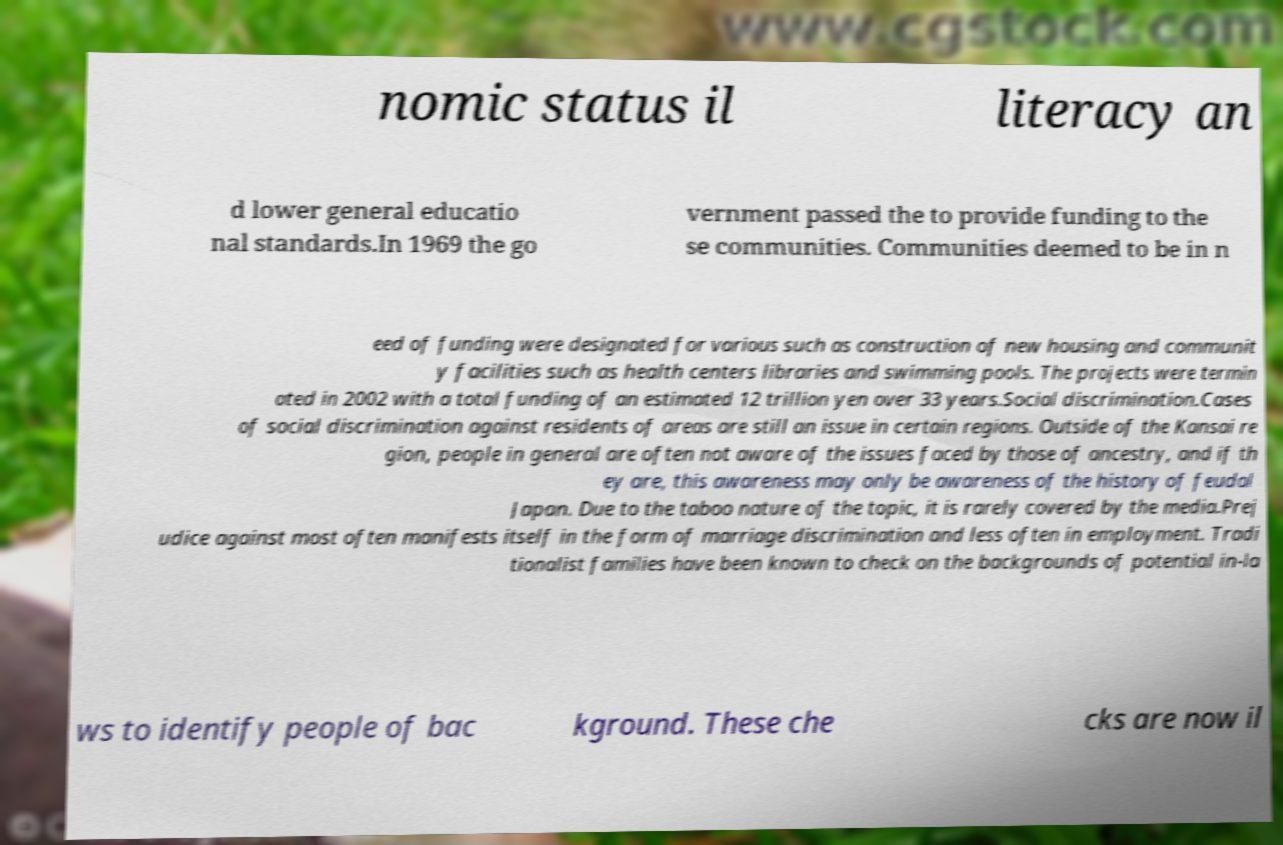Could you assist in decoding the text presented in this image and type it out clearly? nomic status il literacy an d lower general educatio nal standards.In 1969 the go vernment passed the to provide funding to the se communities. Communities deemed to be in n eed of funding were designated for various such as construction of new housing and communit y facilities such as health centers libraries and swimming pools. The projects were termin ated in 2002 with a total funding of an estimated 12 trillion yen over 33 years.Social discrimination.Cases of social discrimination against residents of areas are still an issue in certain regions. Outside of the Kansai re gion, people in general are often not aware of the issues faced by those of ancestry, and if th ey are, this awareness may only be awareness of the history of feudal Japan. Due to the taboo nature of the topic, it is rarely covered by the media.Prej udice against most often manifests itself in the form of marriage discrimination and less often in employment. Tradi tionalist families have been known to check on the backgrounds of potential in-la ws to identify people of bac kground. These che cks are now il 